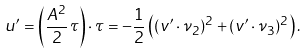<formula> <loc_0><loc_0><loc_500><loc_500>u ^ { \prime } = \left ( \frac { A ^ { 2 } } { 2 } \, \tau \right ) \cdot \tau = - \frac { 1 } { 2 } \left ( ( v ^ { \prime } \cdot \nu _ { 2 } ) ^ { 2 } + ( v ^ { \prime } \cdot \nu _ { 3 } ) ^ { 2 } \right ) .</formula> 